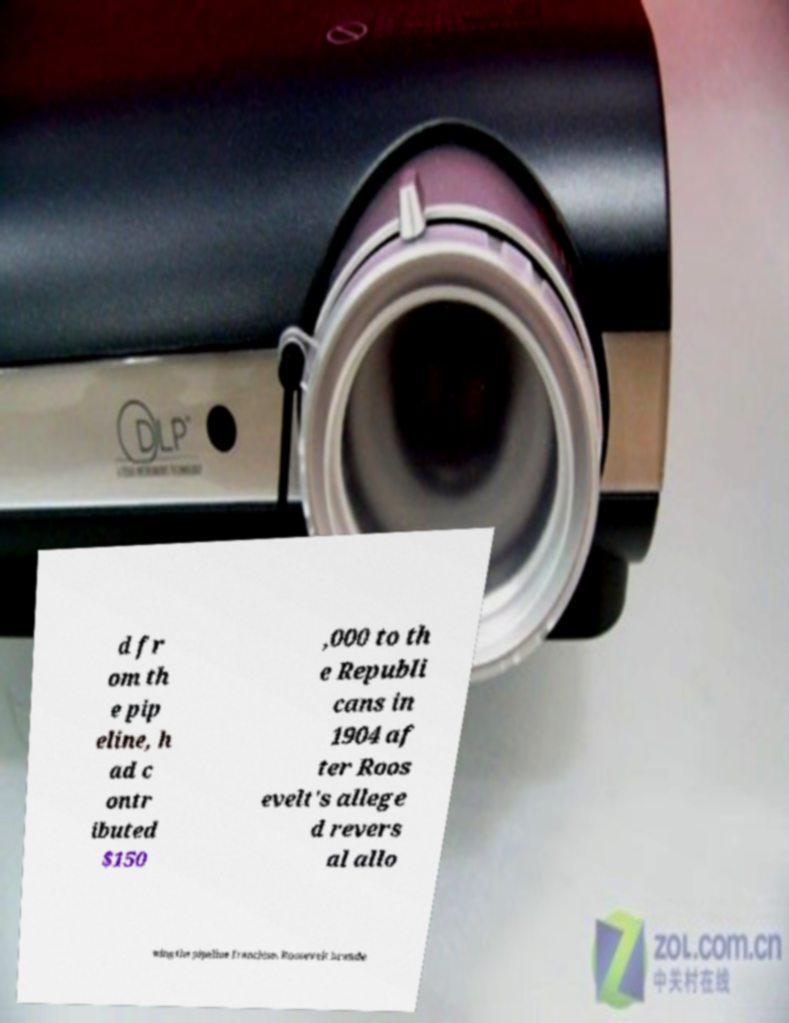Please identify and transcribe the text found in this image. d fr om th e pip eline, h ad c ontr ibuted $150 ,000 to th e Republi cans in 1904 af ter Roos evelt's allege d revers al allo wing the pipeline franchise. Roosevelt brande 